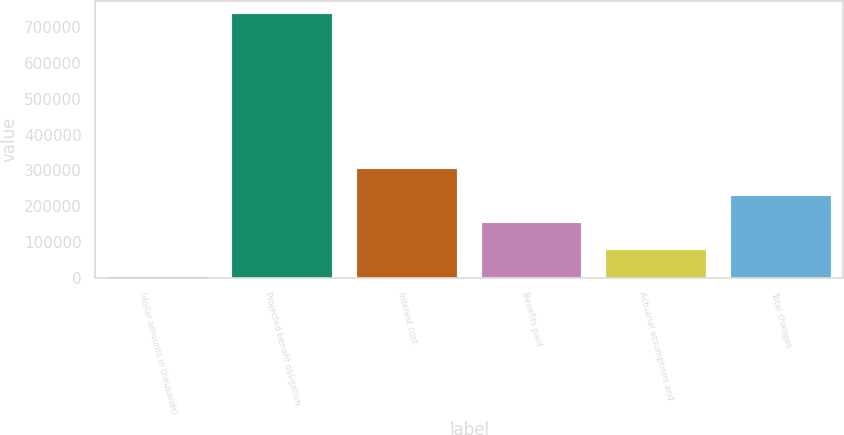Convert chart to OTSL. <chart><loc_0><loc_0><loc_500><loc_500><bar_chart><fcel>(dollar amounts in thousands)<fcel>Projected benefit obligation<fcel>Interest cost<fcel>Benefits paid<fcel>Actuarial assumptions and<fcel>Total changes<nl><fcel>2016<fcel>736346<fcel>303095<fcel>152556<fcel>77285.8<fcel>227825<nl></chart> 